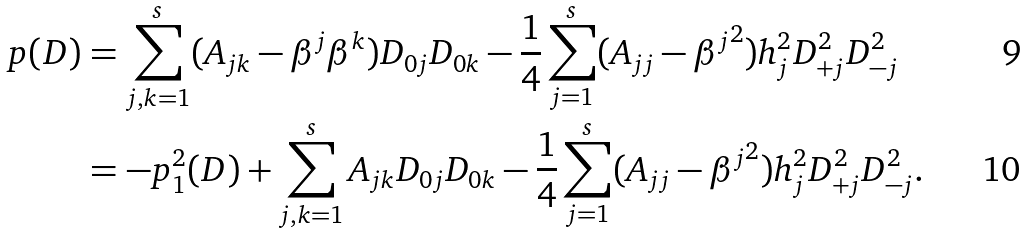<formula> <loc_0><loc_0><loc_500><loc_500>p ( D ) & = \sum _ { j , k = 1 } ^ { s } ( A _ { j k } - \beta ^ { j } \beta ^ { k } ) D _ { 0 j } D _ { 0 k } - \frac { 1 } { 4 } \sum _ { j = 1 } ^ { s } ( A _ { j j } - { \beta ^ { j } } ^ { 2 } ) h _ { j } ^ { 2 } D ^ { 2 } _ { + j } D ^ { 2 } _ { - j } \\ & = - p _ { 1 } ^ { 2 } ( D ) + \sum _ { j , k = 1 } ^ { s } A _ { j k } D _ { 0 j } D _ { 0 k } - \frac { 1 } { 4 } \sum _ { j = 1 } ^ { s } ( A _ { j j } - { \beta ^ { j } } ^ { 2 } ) h _ { j } ^ { 2 } D ^ { 2 } _ { + j } D ^ { 2 } _ { - j } .</formula> 